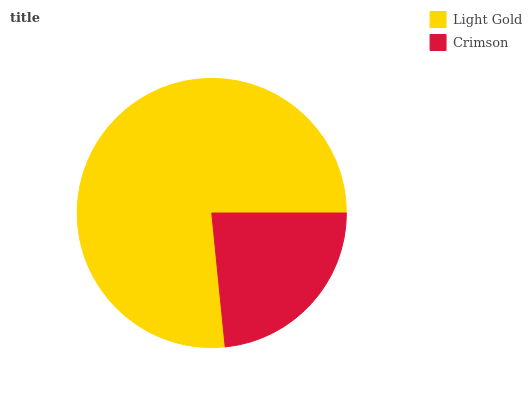Is Crimson the minimum?
Answer yes or no. Yes. Is Light Gold the maximum?
Answer yes or no. Yes. Is Crimson the maximum?
Answer yes or no. No. Is Light Gold greater than Crimson?
Answer yes or no. Yes. Is Crimson less than Light Gold?
Answer yes or no. Yes. Is Crimson greater than Light Gold?
Answer yes or no. No. Is Light Gold less than Crimson?
Answer yes or no. No. Is Light Gold the high median?
Answer yes or no. Yes. Is Crimson the low median?
Answer yes or no. Yes. Is Crimson the high median?
Answer yes or no. No. Is Light Gold the low median?
Answer yes or no. No. 